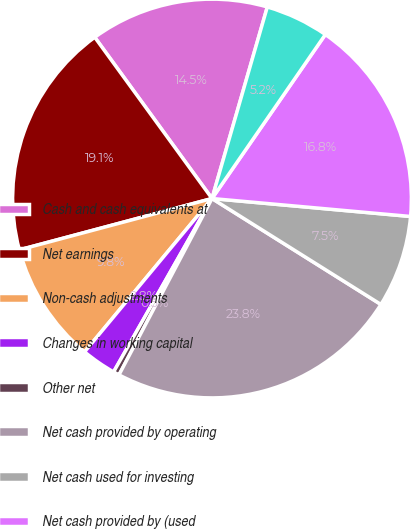<chart> <loc_0><loc_0><loc_500><loc_500><pie_chart><fcel>Cash and cash equivalents at<fcel>Net earnings<fcel>Non-cash adjustments<fcel>Changes in working capital<fcel>Other net<fcel>Net cash provided by operating<fcel>Net cash used for investing<fcel>Net cash provided by (used<fcel>Net change in cash and cash<nl><fcel>14.48%<fcel>19.14%<fcel>9.82%<fcel>2.82%<fcel>0.49%<fcel>23.81%<fcel>7.48%<fcel>16.81%<fcel>5.15%<nl></chart> 